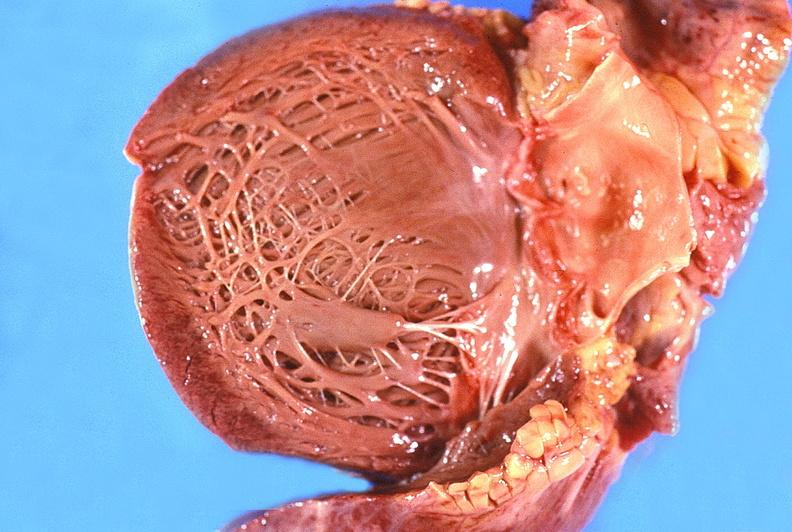does this image show normal aortic valve?
Answer the question using a single word or phrase. Yes 